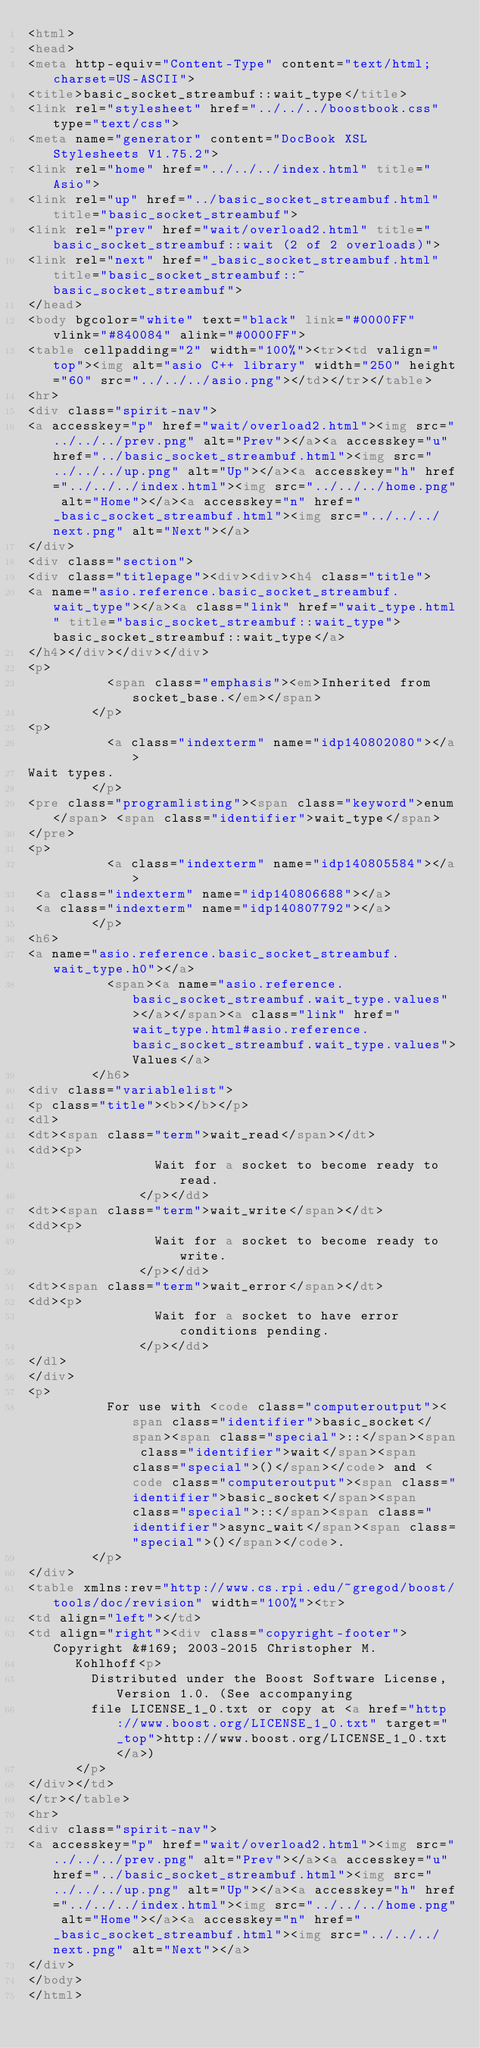<code> <loc_0><loc_0><loc_500><loc_500><_HTML_><html>
<head>
<meta http-equiv="Content-Type" content="text/html; charset=US-ASCII">
<title>basic_socket_streambuf::wait_type</title>
<link rel="stylesheet" href="../../../boostbook.css" type="text/css">
<meta name="generator" content="DocBook XSL Stylesheets V1.75.2">
<link rel="home" href="../../../index.html" title="Asio">
<link rel="up" href="../basic_socket_streambuf.html" title="basic_socket_streambuf">
<link rel="prev" href="wait/overload2.html" title="basic_socket_streambuf::wait (2 of 2 overloads)">
<link rel="next" href="_basic_socket_streambuf.html" title="basic_socket_streambuf::~basic_socket_streambuf">
</head>
<body bgcolor="white" text="black" link="#0000FF" vlink="#840084" alink="#0000FF">
<table cellpadding="2" width="100%"><tr><td valign="top"><img alt="asio C++ library" width="250" height="60" src="../../../asio.png"></td></tr></table>
<hr>
<div class="spirit-nav">
<a accesskey="p" href="wait/overload2.html"><img src="../../../prev.png" alt="Prev"></a><a accesskey="u" href="../basic_socket_streambuf.html"><img src="../../../up.png" alt="Up"></a><a accesskey="h" href="../../../index.html"><img src="../../../home.png" alt="Home"></a><a accesskey="n" href="_basic_socket_streambuf.html"><img src="../../../next.png" alt="Next"></a>
</div>
<div class="section">
<div class="titlepage"><div><div><h4 class="title">
<a name="asio.reference.basic_socket_streambuf.wait_type"></a><a class="link" href="wait_type.html" title="basic_socket_streambuf::wait_type">basic_socket_streambuf::wait_type</a>
</h4></div></div></div>
<p>
          <span class="emphasis"><em>Inherited from socket_base.</em></span>
        </p>
<p>
          <a class="indexterm" name="idp140802080"></a> 
Wait types.
        </p>
<pre class="programlisting"><span class="keyword">enum</span> <span class="identifier">wait_type</span>
</pre>
<p>
          <a class="indexterm" name="idp140805584"></a>
 <a class="indexterm" name="idp140806688"></a>
 <a class="indexterm" name="idp140807792"></a>
        </p>
<h6>
<a name="asio.reference.basic_socket_streambuf.wait_type.h0"></a>
          <span><a name="asio.reference.basic_socket_streambuf.wait_type.values"></a></span><a class="link" href="wait_type.html#asio.reference.basic_socket_streambuf.wait_type.values">Values</a>
        </h6>
<div class="variablelist">
<p class="title"><b></b></p>
<dl>
<dt><span class="term">wait_read</span></dt>
<dd><p>
                Wait for a socket to become ready to read.
              </p></dd>
<dt><span class="term">wait_write</span></dt>
<dd><p>
                Wait for a socket to become ready to write.
              </p></dd>
<dt><span class="term">wait_error</span></dt>
<dd><p>
                Wait for a socket to have error conditions pending.
              </p></dd>
</dl>
</div>
<p>
          For use with <code class="computeroutput"><span class="identifier">basic_socket</span><span class="special">::</span><span class="identifier">wait</span><span class="special">()</span></code> and <code class="computeroutput"><span class="identifier">basic_socket</span><span class="special">::</span><span class="identifier">async_wait</span><span class="special">()</span></code>.
        </p>
</div>
<table xmlns:rev="http://www.cs.rpi.edu/~gregod/boost/tools/doc/revision" width="100%"><tr>
<td align="left"></td>
<td align="right"><div class="copyright-footer">Copyright &#169; 2003-2015 Christopher M.
      Kohlhoff<p>
        Distributed under the Boost Software License, Version 1.0. (See accompanying
        file LICENSE_1_0.txt or copy at <a href="http://www.boost.org/LICENSE_1_0.txt" target="_top">http://www.boost.org/LICENSE_1_0.txt</a>)
      </p>
</div></td>
</tr></table>
<hr>
<div class="spirit-nav">
<a accesskey="p" href="wait/overload2.html"><img src="../../../prev.png" alt="Prev"></a><a accesskey="u" href="../basic_socket_streambuf.html"><img src="../../../up.png" alt="Up"></a><a accesskey="h" href="../../../index.html"><img src="../../../home.png" alt="Home"></a><a accesskey="n" href="_basic_socket_streambuf.html"><img src="../../../next.png" alt="Next"></a>
</div>
</body>
</html>
</code> 